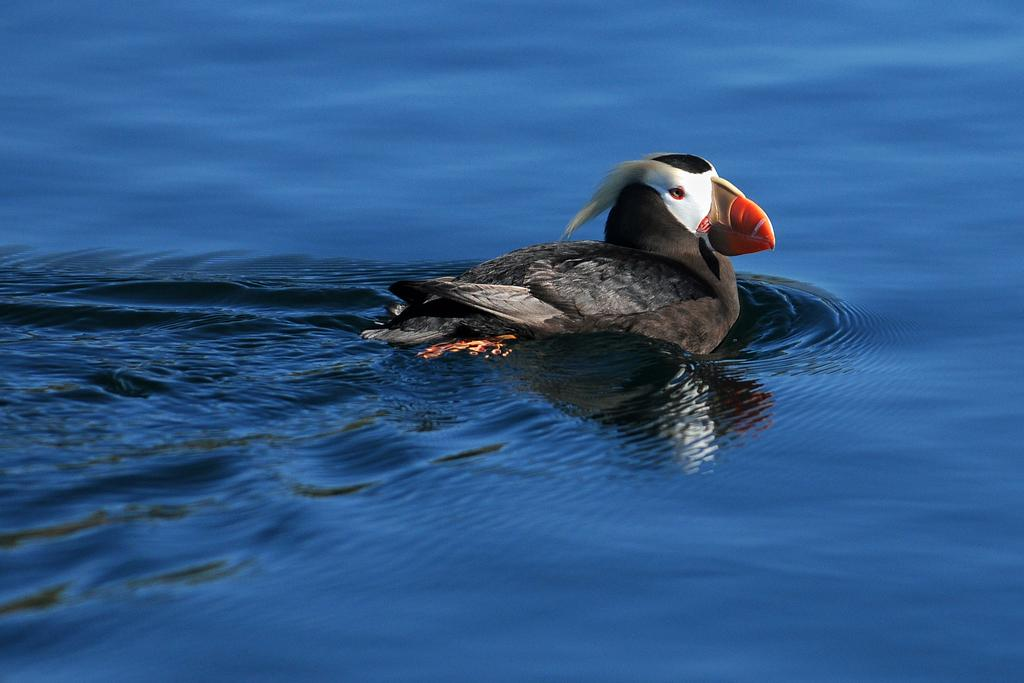What type of animals are in the image? There are puffins in the image. Where are the puffins located? The puffins are in the water. Can you describe the position of the puffins in the image? The puffins are in the center of the image. What type of bait is being used to catch the puffins in the image? There is no bait or fishing activity depicted in the image; it simply shows puffins in the water. 